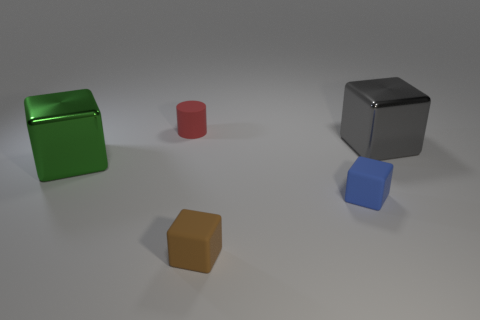Subtract all big green blocks. How many blocks are left? 3 Subtract all brown blocks. How many blocks are left? 3 Add 1 tiny matte cylinders. How many objects exist? 6 Subtract 2 cubes. How many cubes are left? 2 Subtract all purple cubes. Subtract all purple cylinders. How many cubes are left? 4 Subtract all cylinders. How many objects are left? 4 Subtract all cylinders. Subtract all large gray objects. How many objects are left? 3 Add 4 tiny blue matte blocks. How many tiny blue matte blocks are left? 5 Add 1 big green shiny balls. How many big green shiny balls exist? 1 Subtract 0 blue cylinders. How many objects are left? 5 